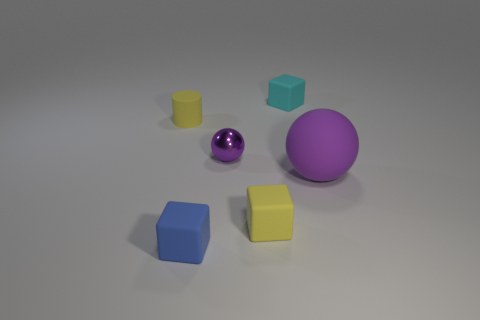Add 1 small objects. How many objects exist? 7 Subtract all cyan cubes. How many cubes are left? 2 Subtract all blue blocks. How many blocks are left? 2 Subtract 0 cyan cylinders. How many objects are left? 6 Subtract all balls. How many objects are left? 4 Subtract 2 cubes. How many cubes are left? 1 Subtract all purple blocks. Subtract all brown spheres. How many blocks are left? 3 Subtract all green cylinders. How many purple blocks are left? 0 Subtract all small blue things. Subtract all gray spheres. How many objects are left? 5 Add 5 tiny things. How many tiny things are left? 10 